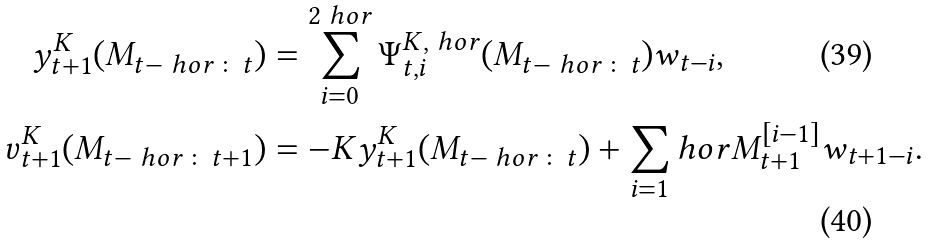<formula> <loc_0><loc_0><loc_500><loc_500>y ^ { K } _ { t + 1 } ( M _ { t - \ h o r \colon t } ) & = \sum _ { i = 0 } ^ { 2 \ h o r } \Psi _ { t , i } ^ { K , \ h o r } ( M _ { t - \ h o r \colon t } ) w _ { t - i } , \\ v _ { t + 1 } ^ { K } ( M _ { t - \ h o r \colon t + 1 } ) & = - K y ^ { K } _ { t + 1 } ( M _ { t - \ h o r \colon t } ) + \sum _ { i = 1 } ^ { \ } h o r M _ { t + 1 } ^ { [ i - 1 ] } w _ { t + 1 - i } .</formula> 